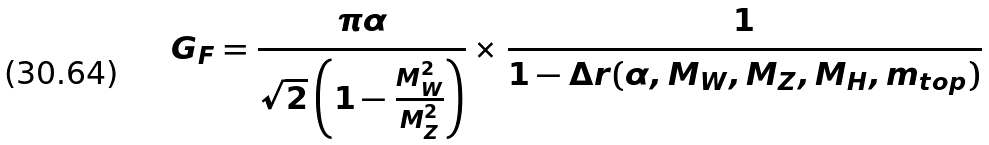Convert formula to latex. <formula><loc_0><loc_0><loc_500><loc_500>G _ { F } = \frac { \pi \alpha } { \sqrt { 2 } \left ( 1 - \frac { M _ { W } ^ { 2 } } { M _ { Z } ^ { 2 } } \right ) } \times \frac { 1 } { 1 - \Delta r ( \alpha , M _ { W } , M _ { Z } , M _ { H } , m _ { t o p } ) }</formula> 